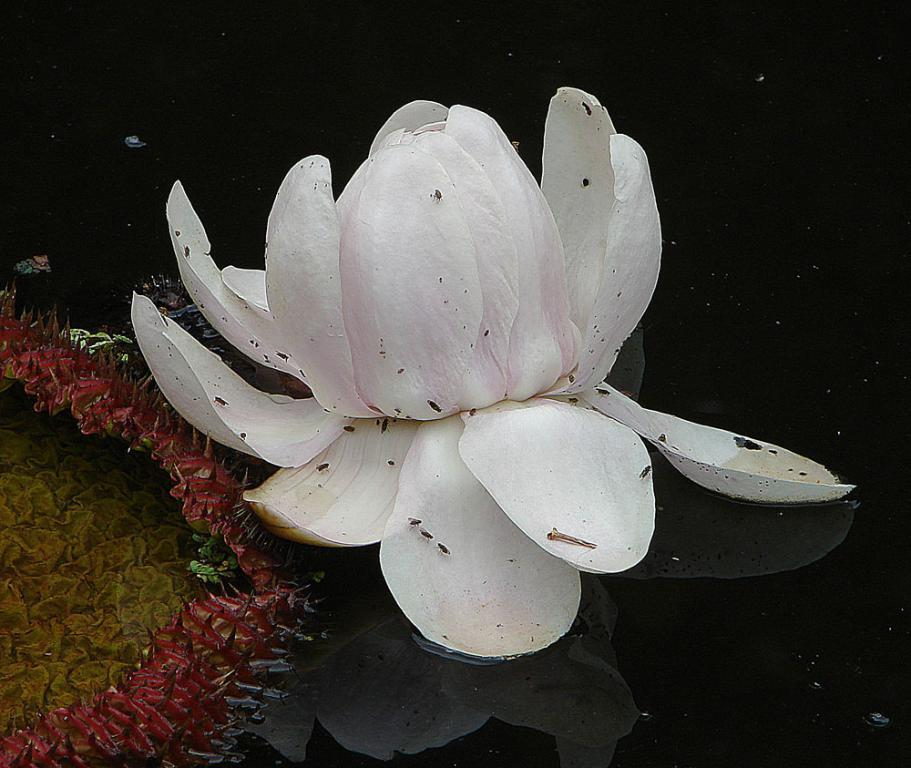What type of plant is in the image? There is a lotus in the image. What color is the lotus? The lotus is white in color. Where is the lotus located? The lotus is in a water pond. What other plants can be seen in the image? There are flowers on the left side of the image. What colors are the flowers? The flowers are in yellow and pink colors. What type of metal is used to create the curve in the image? There is no metal or curve present in the image; it features a lotus in a water pond and flowers on the left side. 